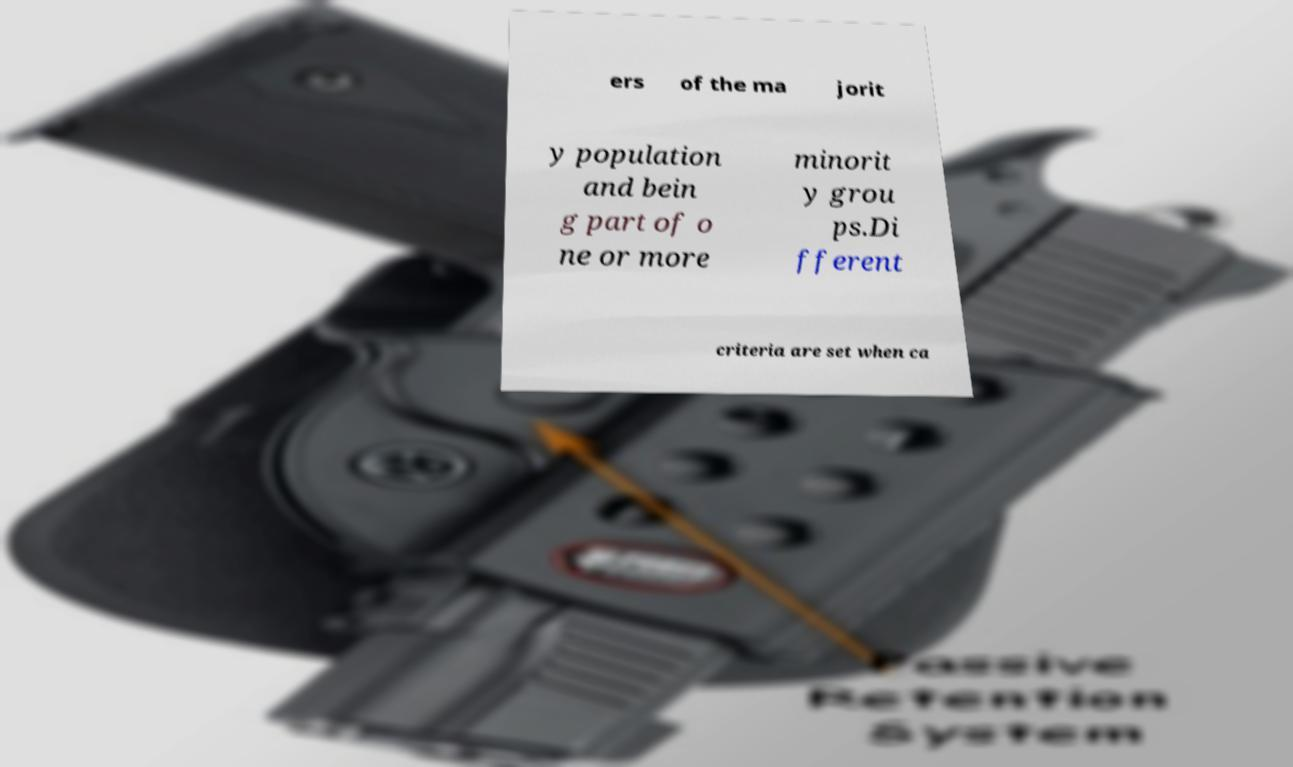Could you assist in decoding the text presented in this image and type it out clearly? ers of the ma jorit y population and bein g part of o ne or more minorit y grou ps.Di fferent criteria are set when ca 